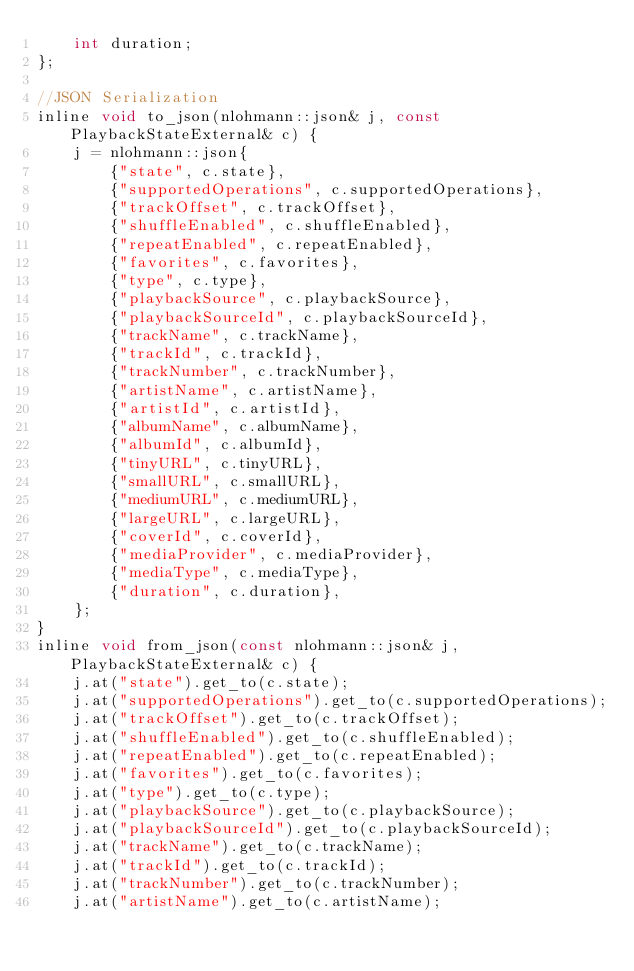<code> <loc_0><loc_0><loc_500><loc_500><_C_>    int duration;
};

//JSON Serialization
inline void to_json(nlohmann::json& j, const PlaybackStateExternal& c) {
    j = nlohmann::json{
        {"state", c.state},
        {"supportedOperations", c.supportedOperations},
        {"trackOffset", c.trackOffset},
        {"shuffleEnabled", c.shuffleEnabled},
        {"repeatEnabled", c.repeatEnabled},
        {"favorites", c.favorites},
        {"type", c.type},
        {"playbackSource", c.playbackSource},
        {"playbackSourceId", c.playbackSourceId},
        {"trackName", c.trackName},
        {"trackId", c.trackId},
        {"trackNumber", c.trackNumber},
        {"artistName", c.artistName},
        {"artistId", c.artistId},
        {"albumName", c.albumName},
        {"albumId", c.albumId},
        {"tinyURL", c.tinyURL},
        {"smallURL", c.smallURL},
        {"mediumURL", c.mediumURL},
        {"largeURL", c.largeURL},
        {"coverId", c.coverId},
        {"mediaProvider", c.mediaProvider},
        {"mediaType", c.mediaType},
        {"duration", c.duration},
    };
}
inline void from_json(const nlohmann::json& j, PlaybackStateExternal& c) {
    j.at("state").get_to(c.state);
    j.at("supportedOperations").get_to(c.supportedOperations);
    j.at("trackOffset").get_to(c.trackOffset);
    j.at("shuffleEnabled").get_to(c.shuffleEnabled);
    j.at("repeatEnabled").get_to(c.repeatEnabled);
    j.at("favorites").get_to(c.favorites);
    j.at("type").get_to(c.type);
    j.at("playbackSource").get_to(c.playbackSource);
    j.at("playbackSourceId").get_to(c.playbackSourceId);
    j.at("trackName").get_to(c.trackName);
    j.at("trackId").get_to(c.trackId);
    j.at("trackNumber").get_to(c.trackNumber);
    j.at("artistName").get_to(c.artistName);</code> 